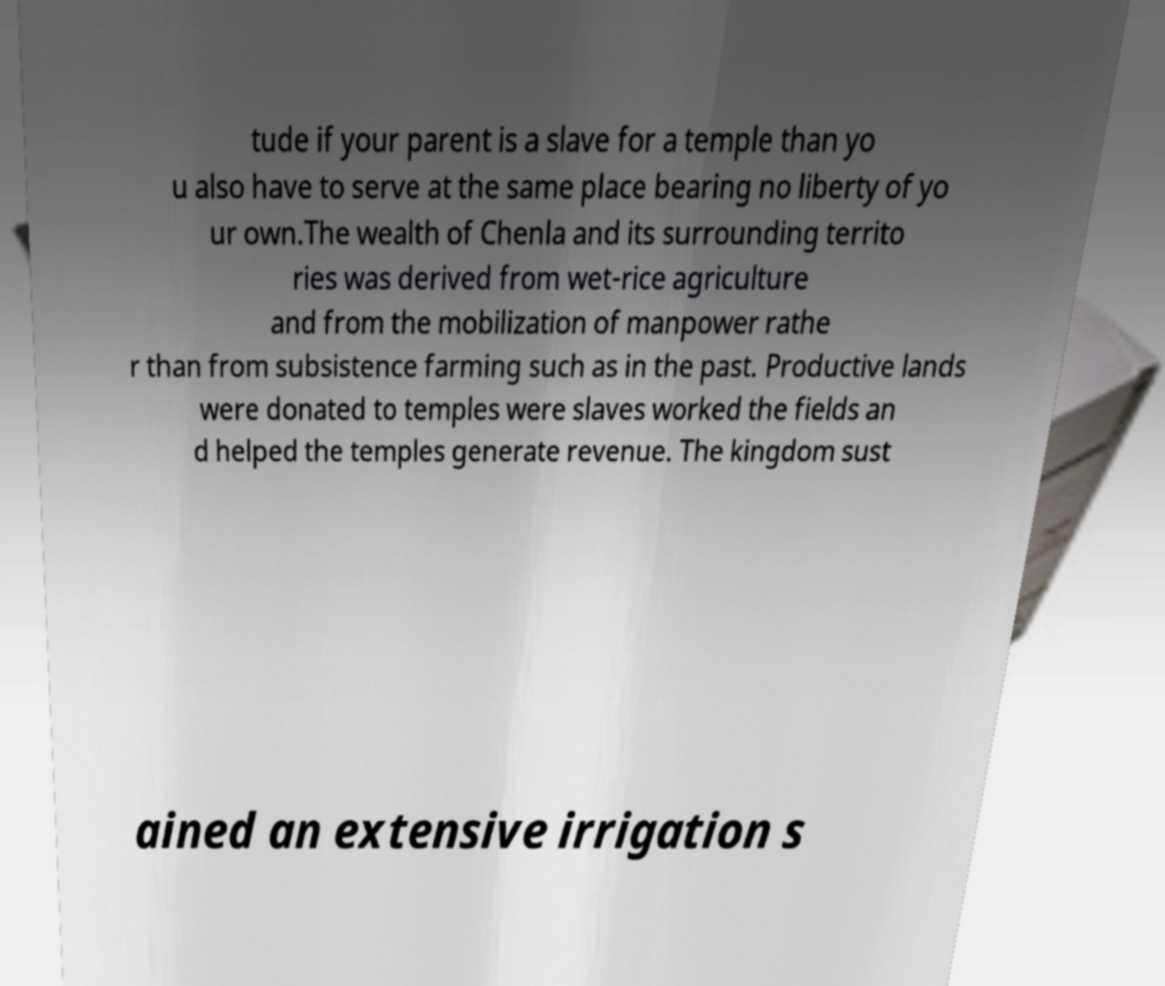For documentation purposes, I need the text within this image transcribed. Could you provide that? tude if your parent is a slave for a temple than yo u also have to serve at the same place bearing no liberty of yo ur own.The wealth of Chenla and its surrounding territo ries was derived from wet-rice agriculture and from the mobilization of manpower rathe r than from subsistence farming such as in the past. Productive lands were donated to temples were slaves worked the fields an d helped the temples generate revenue. The kingdom sust ained an extensive irrigation s 